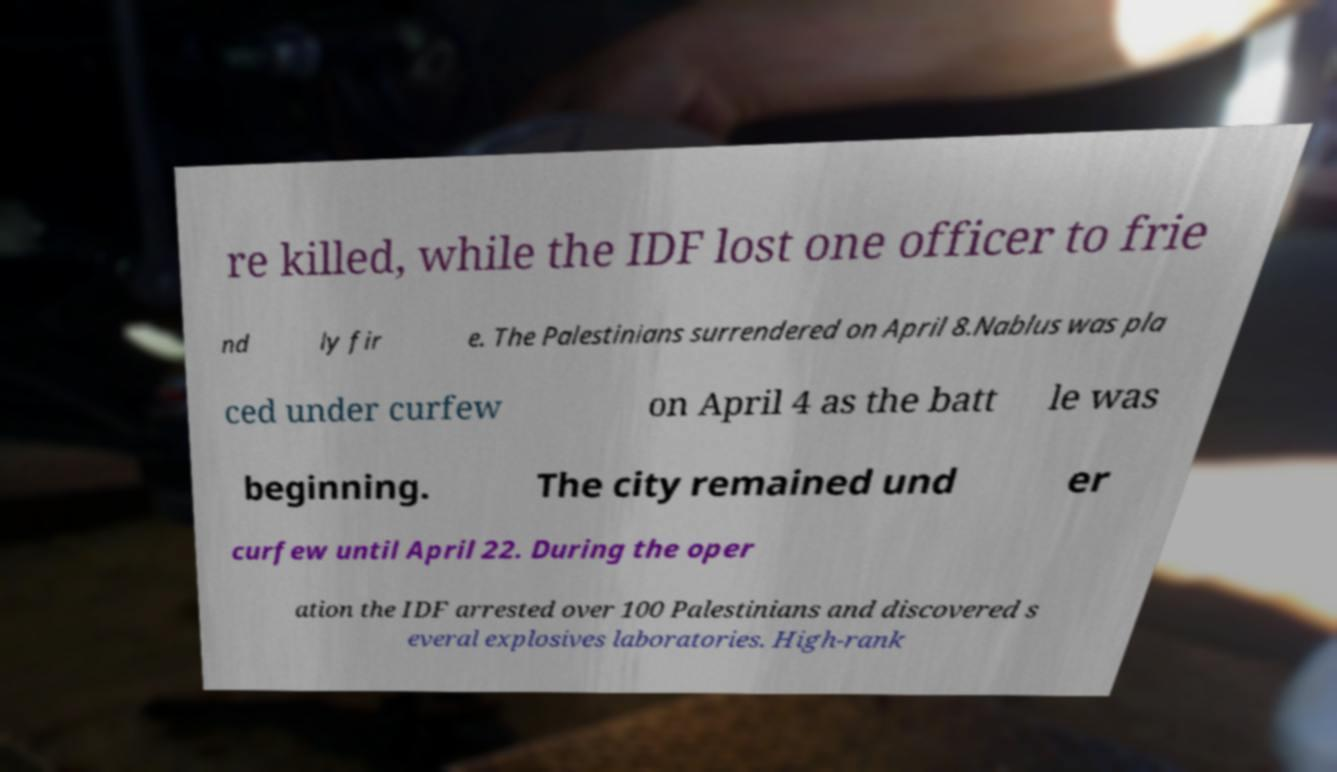Could you extract and type out the text from this image? re killed, while the IDF lost one officer to frie nd ly fir e. The Palestinians surrendered on April 8.Nablus was pla ced under curfew on April 4 as the batt le was beginning. The city remained und er curfew until April 22. During the oper ation the IDF arrested over 100 Palestinians and discovered s everal explosives laboratories. High-rank 